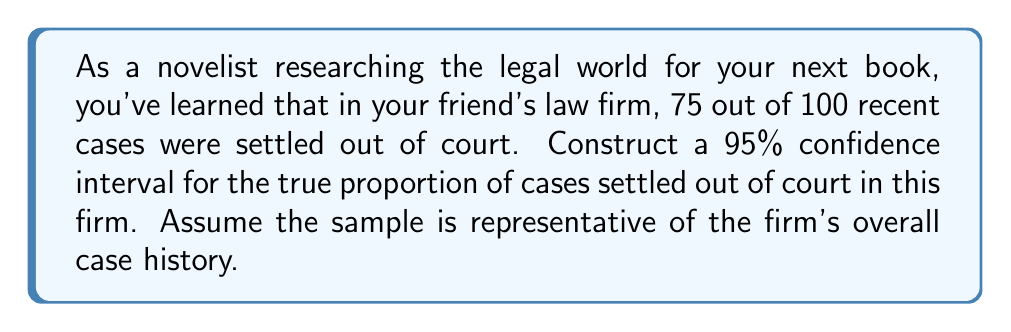Could you help me with this problem? Let's approach this step-by-step:

1) We're dealing with a proportion, so we'll use the formula for a confidence interval for a proportion:

   $$\hat{p} \pm z^* \sqrt{\frac{\hat{p}(1-\hat{p})}{n}}$$

   Where:
   $\hat{p}$ = sample proportion
   $z^*$ = critical value for desired confidence level
   $n$ = sample size

2) Given:
   $\hat{p} = 75/100 = 0.75$
   $n = 100$
   Confidence level = 95%, so $z^* = 1.96$

3) Plug these values into the formula:

   $$0.75 \pm 1.96 \sqrt{\frac{0.75(1-0.75)}{100}}$$

4) Simplify under the square root:

   $$0.75 \pm 1.96 \sqrt{\frac{0.75(0.25)}{100}} = 0.75 \pm 1.96 \sqrt{0.001875}$$

5) Calculate:

   $$0.75 \pm 1.96(0.0433) = 0.75 \pm 0.0849$$

6) Therefore, the confidence interval is:

   $$(0.75 - 0.0849, 0.75 + 0.0849) = (0.6651, 0.8349)$$

7) We can say we are 95% confident that the true proportion of cases settled out of court in this firm is between 0.6651 and 0.8349, or between 66.51% and 83.49%.
Answer: (0.6651, 0.8349) 